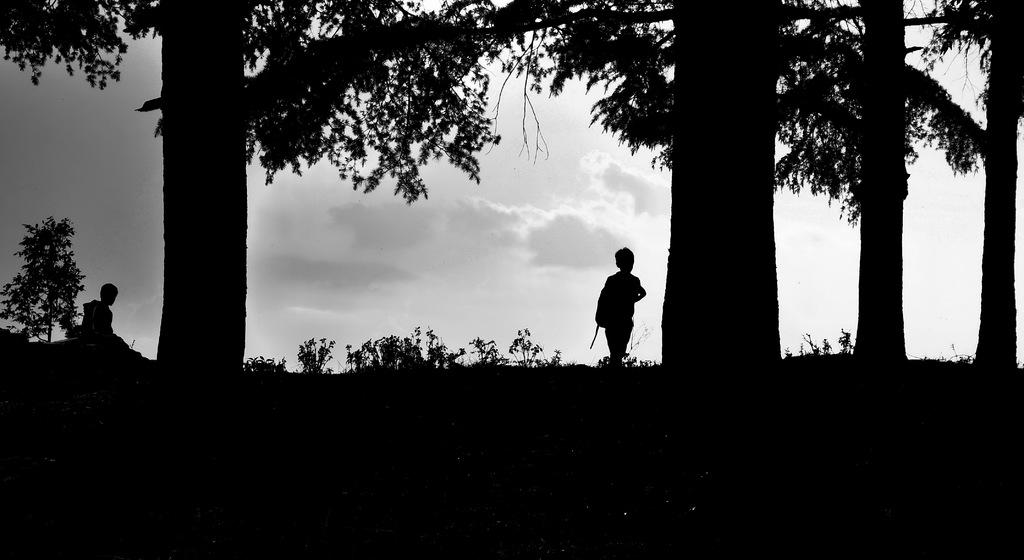How many people are in the image? There are two persons standing in the center of the image. What are the persons wearing? The persons are wearing some objects. What type of vegetation can be seen in the image? Plants and trees are visible in the image. What is visible in the background of the image? The sky is visible in the background of the image. What can be observed in the sky? Clouds are present in the sky. How many ears of corn can be seen in the image? There is no corn present in the image. What type of planes can be seen flying in the image? There are no planes visible in the image. 